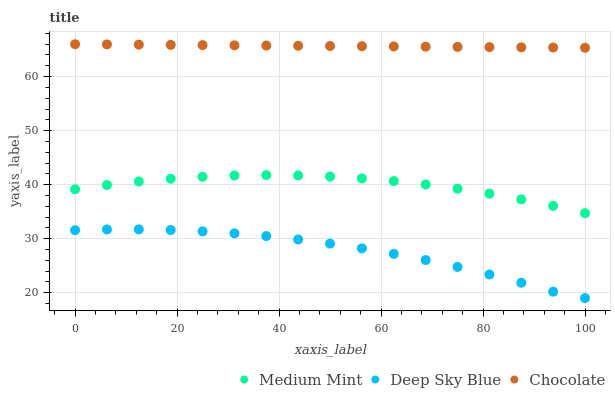Does Deep Sky Blue have the minimum area under the curve?
Answer yes or no. Yes. Does Chocolate have the maximum area under the curve?
Answer yes or no. Yes. Does Chocolate have the minimum area under the curve?
Answer yes or no. No. Does Deep Sky Blue have the maximum area under the curve?
Answer yes or no. No. Is Chocolate the smoothest?
Answer yes or no. Yes. Is Deep Sky Blue the roughest?
Answer yes or no. Yes. Is Deep Sky Blue the smoothest?
Answer yes or no. No. Is Chocolate the roughest?
Answer yes or no. No. Does Deep Sky Blue have the lowest value?
Answer yes or no. Yes. Does Chocolate have the lowest value?
Answer yes or no. No. Does Chocolate have the highest value?
Answer yes or no. Yes. Does Deep Sky Blue have the highest value?
Answer yes or no. No. Is Deep Sky Blue less than Chocolate?
Answer yes or no. Yes. Is Medium Mint greater than Deep Sky Blue?
Answer yes or no. Yes. Does Deep Sky Blue intersect Chocolate?
Answer yes or no. No. 